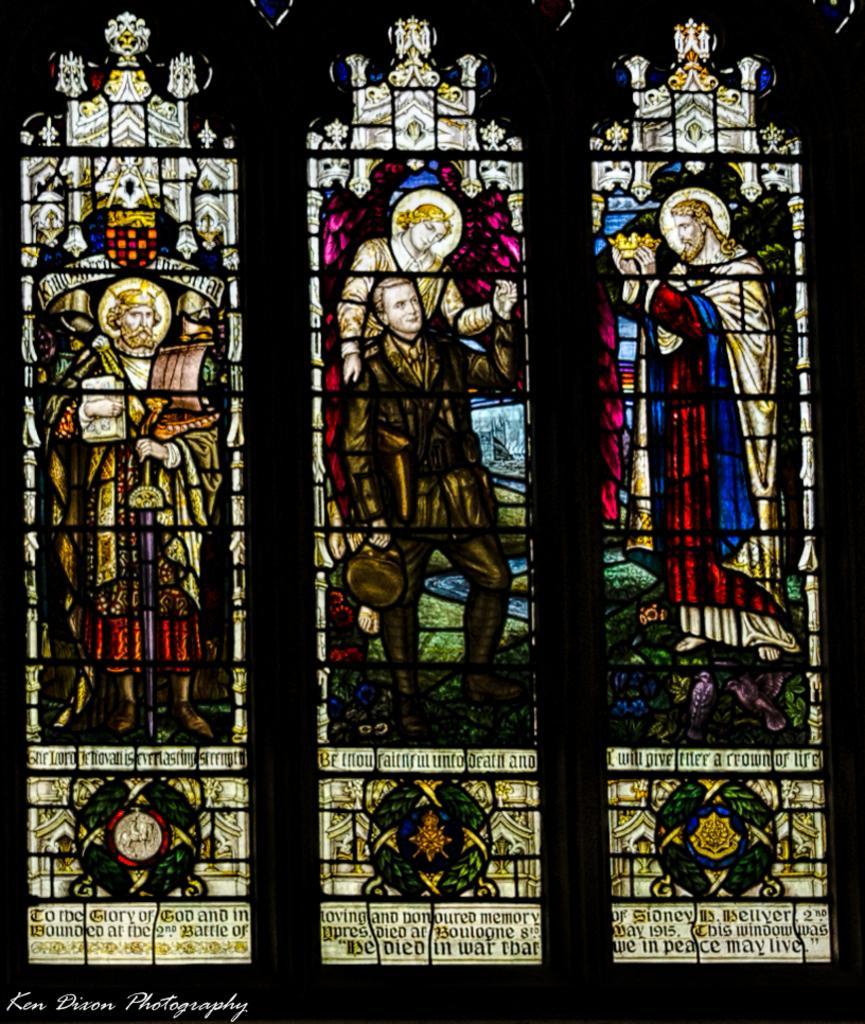Could you give a brief overview of what you see in this image? In this image there are pictures on the glass and some text. 